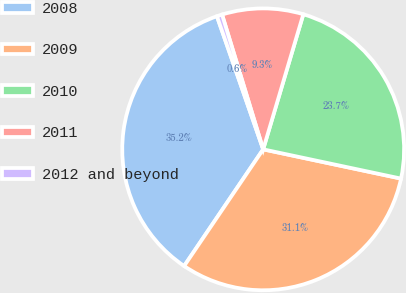<chart> <loc_0><loc_0><loc_500><loc_500><pie_chart><fcel>2008<fcel>2009<fcel>2010<fcel>2011<fcel>2012 and beyond<nl><fcel>35.2%<fcel>31.15%<fcel>23.73%<fcel>9.31%<fcel>0.61%<nl></chart> 